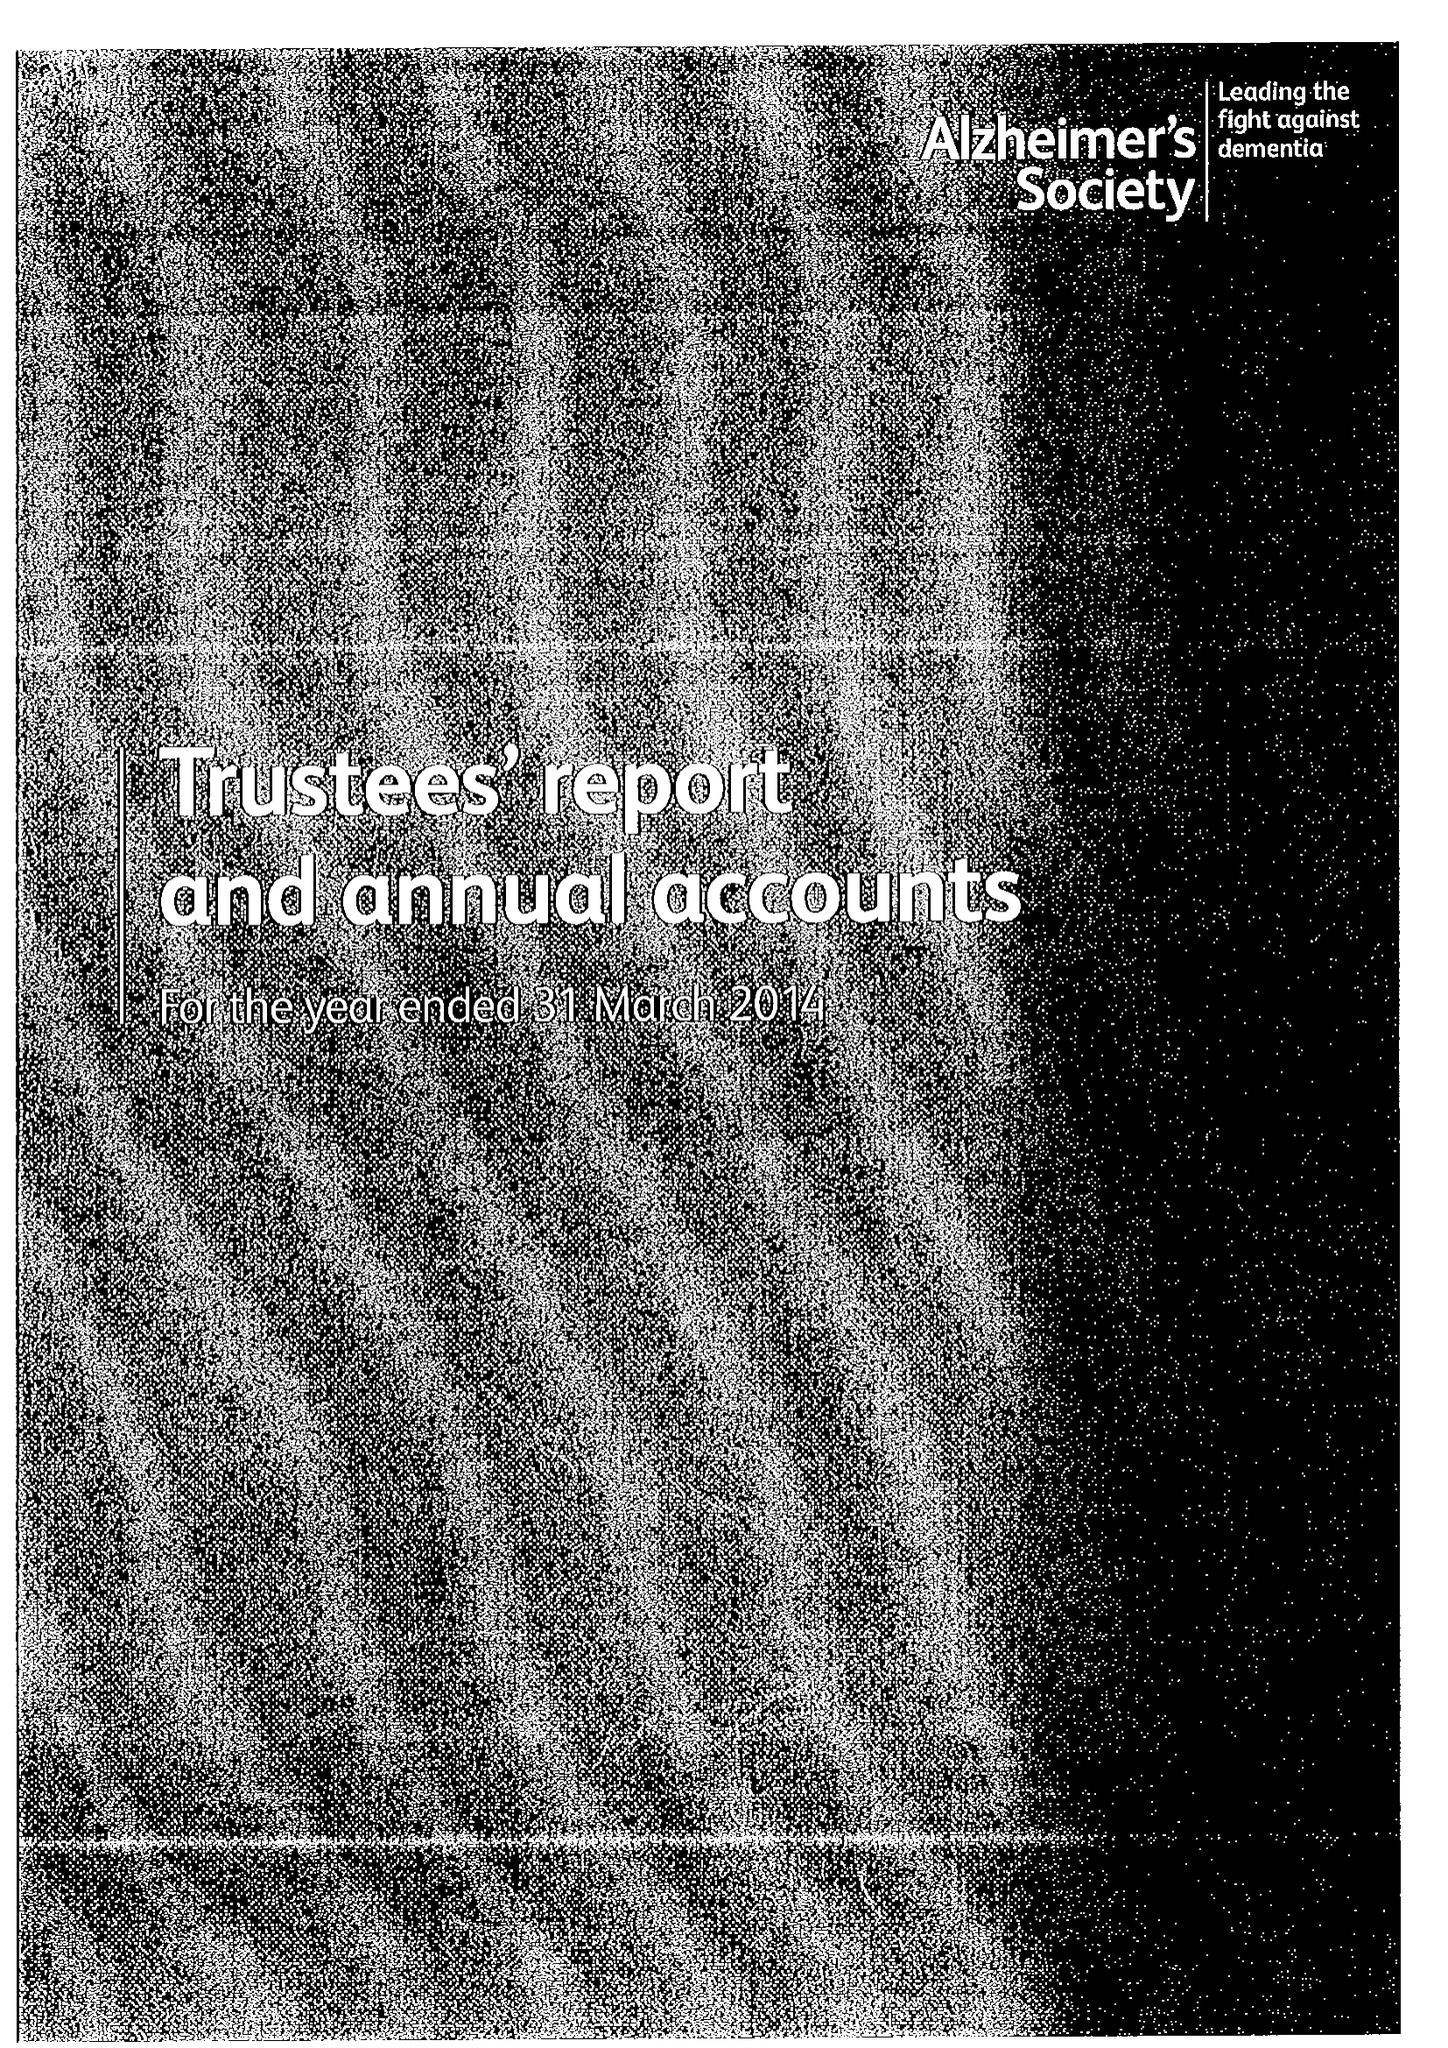What is the value for the charity_number?
Answer the question using a single word or phrase. 296645 